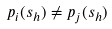<formula> <loc_0><loc_0><loc_500><loc_500>p _ { i } ( s _ { h } ) \ne p _ { j } ( s _ { h } )</formula> 